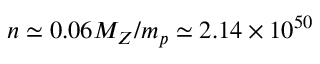Convert formula to latex. <formula><loc_0><loc_0><loc_500><loc_500>n \simeq 0 . 0 6 M _ { Z } / m _ { p } \simeq 2 . 1 4 \times 1 0 ^ { 5 0 }</formula> 